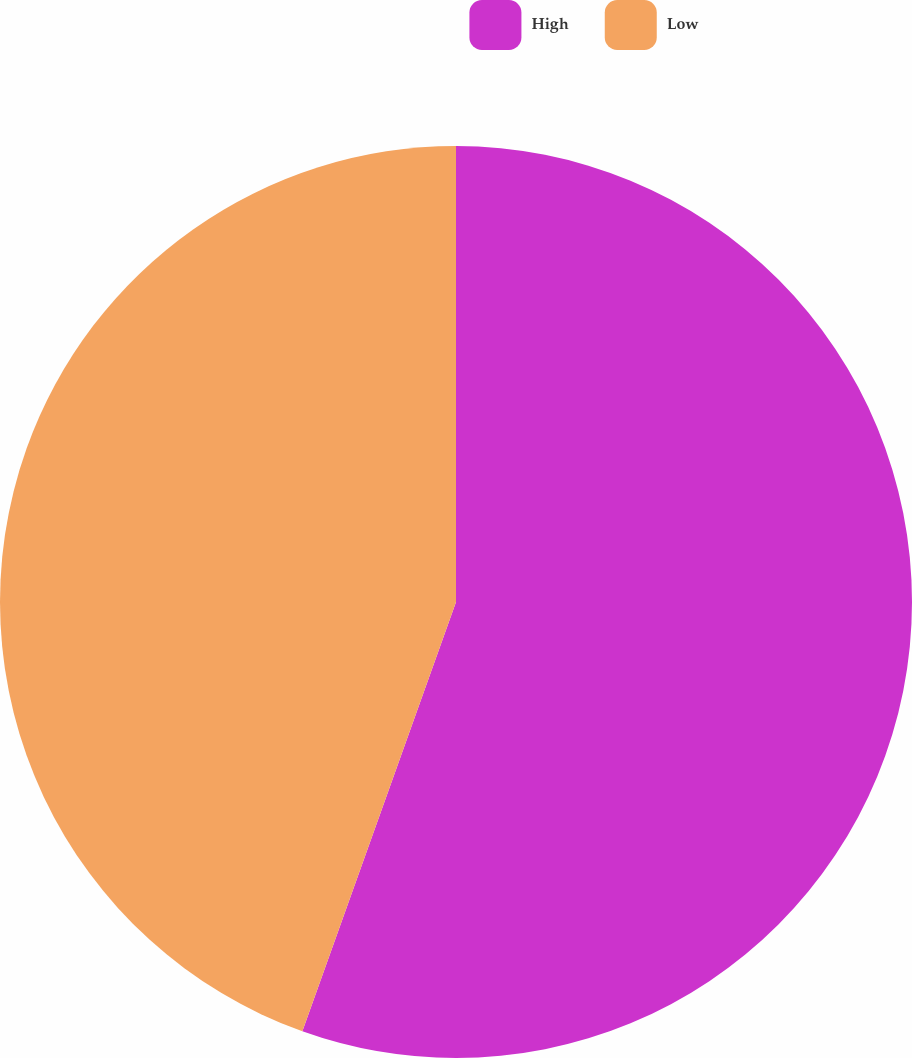<chart> <loc_0><loc_0><loc_500><loc_500><pie_chart><fcel>High<fcel>Low<nl><fcel>55.47%<fcel>44.53%<nl></chart> 